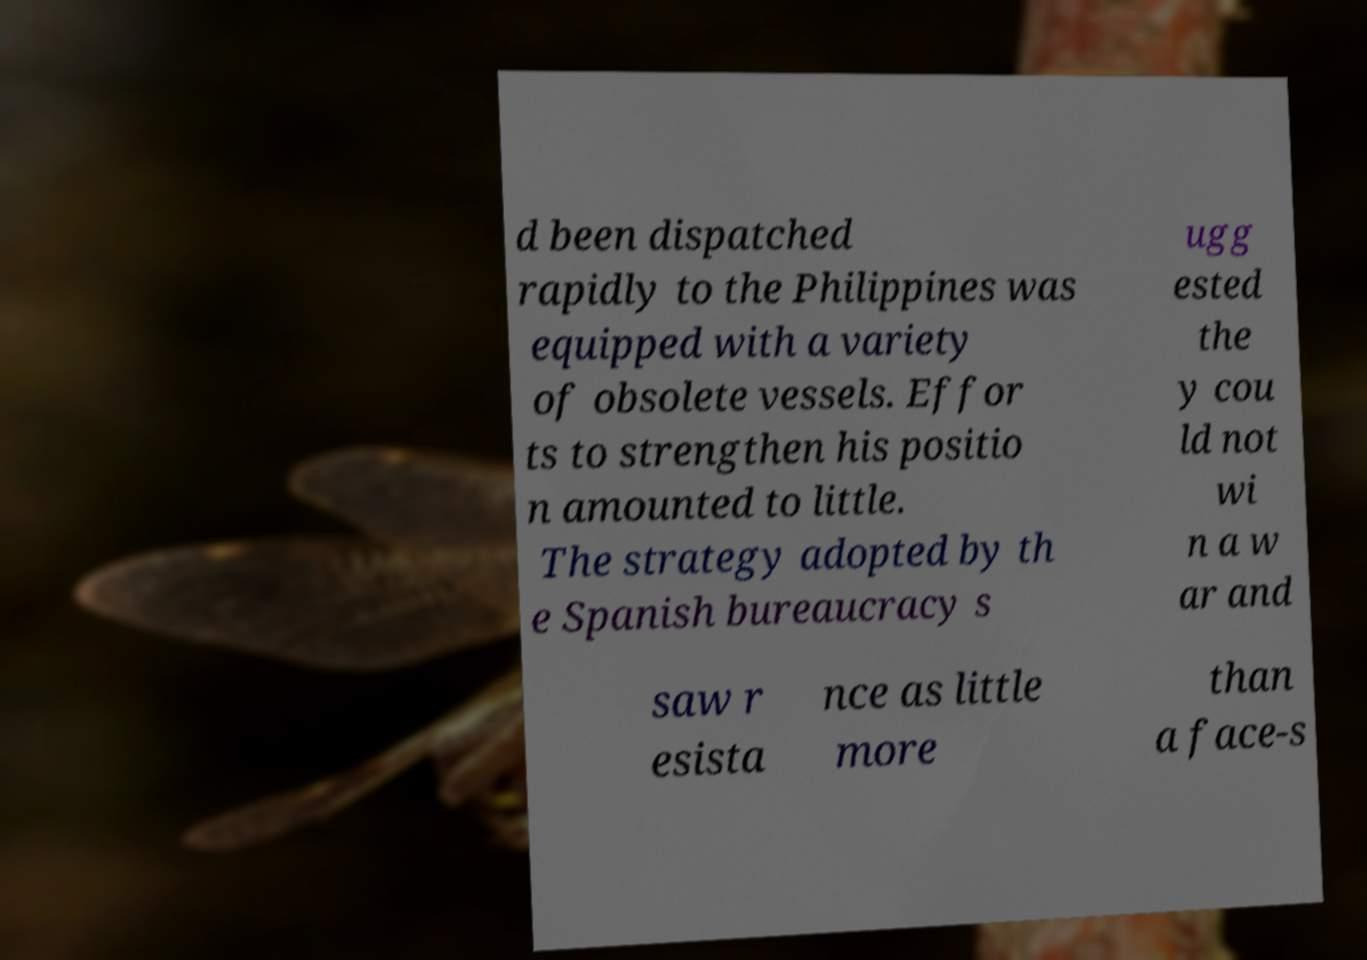Please identify and transcribe the text found in this image. d been dispatched rapidly to the Philippines was equipped with a variety of obsolete vessels. Effor ts to strengthen his positio n amounted to little. The strategy adopted by th e Spanish bureaucracy s ugg ested the y cou ld not wi n a w ar and saw r esista nce as little more than a face-s 